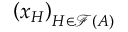<formula> <loc_0><loc_0><loc_500><loc_500>\left ( x _ { H } \right ) _ { H \in { \mathcal { F } } ( A ) }</formula> 